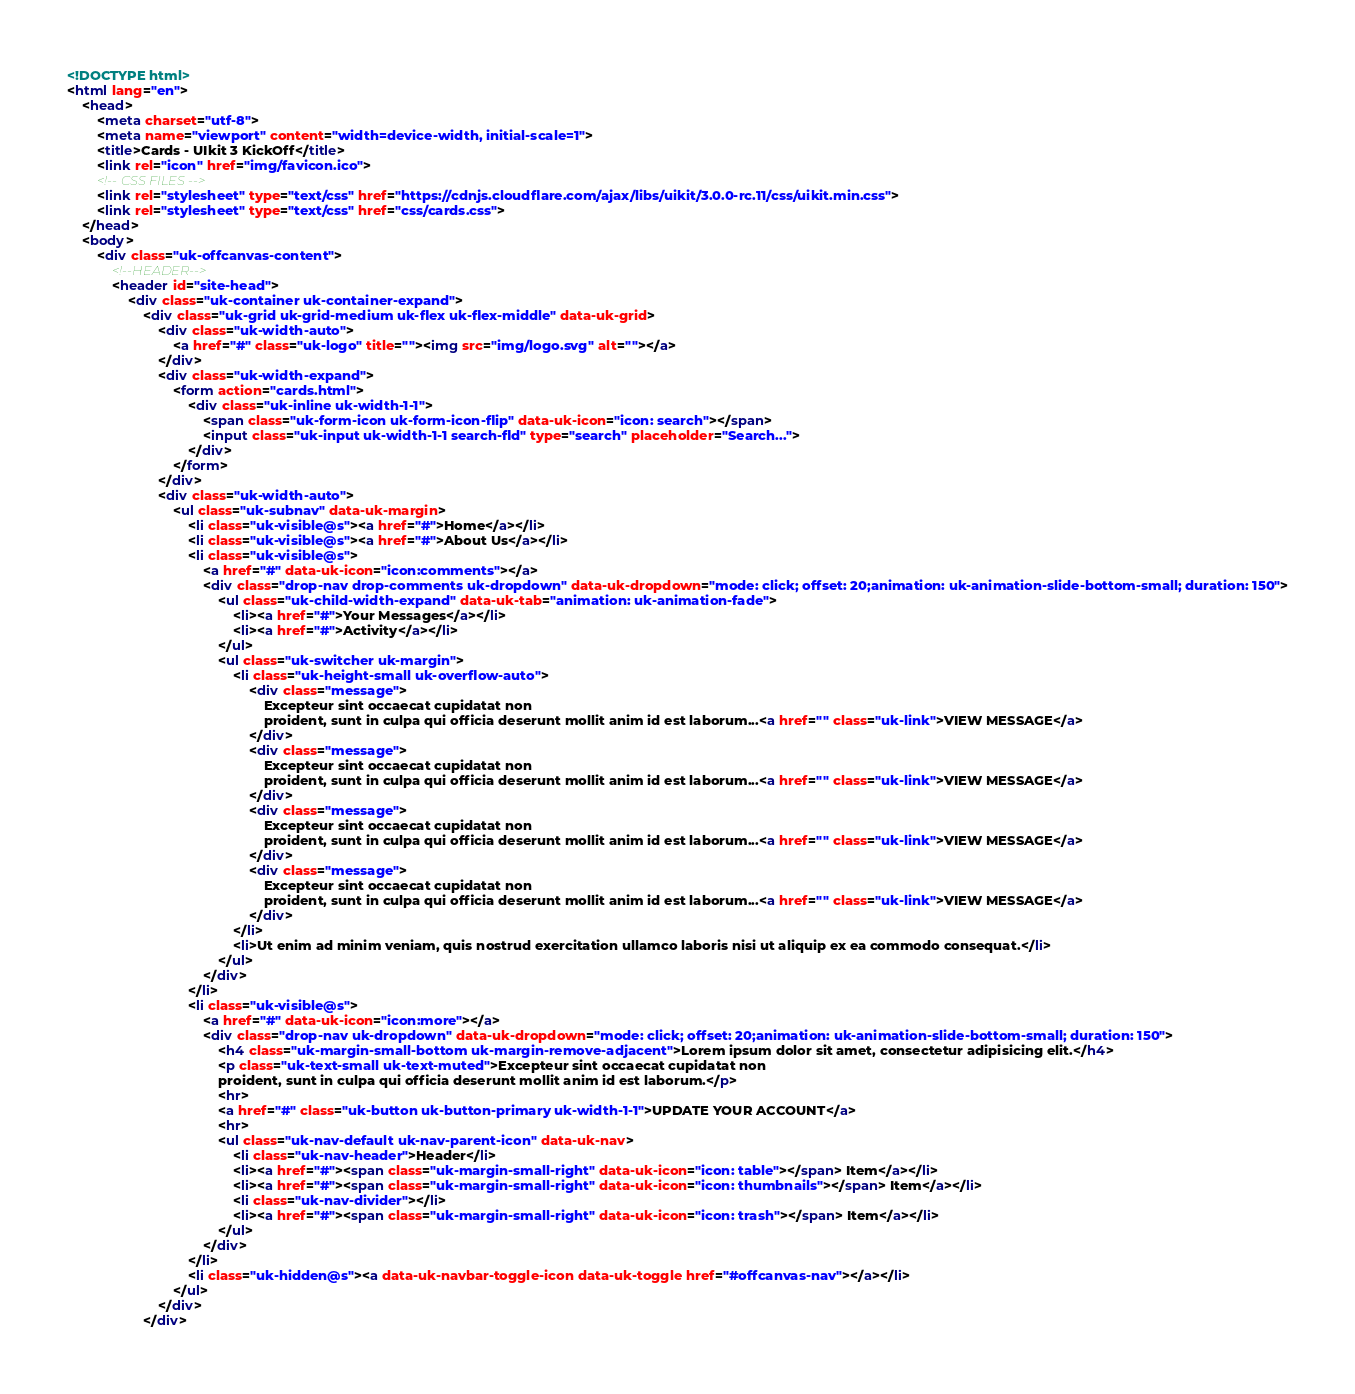Convert code to text. <code><loc_0><loc_0><loc_500><loc_500><_HTML_><!DOCTYPE html>
<html lang="en">
	<head>
		<meta charset="utf-8">
		<meta name="viewport" content="width=device-width, initial-scale=1">
		<title>Cards - UIkit 3 KickOff</title>
		<link rel="icon" href="img/favicon.ico">
		<!-- CSS FILES -->
		<link rel="stylesheet" type="text/css" href="https://cdnjs.cloudflare.com/ajax/libs/uikit/3.0.0-rc.11/css/uikit.min.css">
		<link rel="stylesheet" type="text/css" href="css/cards.css">
	</head>
	<body>
		<div class="uk-offcanvas-content">
			<!--HEADER-->
			<header id="site-head">
				<div class="uk-container uk-container-expand">
					<div class="uk-grid uk-grid-medium uk-flex uk-flex-middle" data-uk-grid>
						<div class="uk-width-auto">
							<a href="#" class="uk-logo" title=""><img src="img/logo.svg" alt=""></a>
						</div>
						<div class="uk-width-expand">
							<form action="cards.html">
								<div class="uk-inline uk-width-1-1">
									<span class="uk-form-icon uk-form-icon-flip" data-uk-icon="icon: search"></span>
									<input class="uk-input uk-width-1-1 search-fld" type="search" placeholder="Search...">
								</div>
							</form>
						</div>
						<div class="uk-width-auto">
							<ul class="uk-subnav" data-uk-margin>
								<li class="uk-visible@s"><a href="#">Home</a></li>
								<li class="uk-visible@s"><a href="#">About Us</a></li>
								<li class="uk-visible@s">
									<a href="#" data-uk-icon="icon:comments"></a>
									<div class="drop-nav drop-comments uk-dropdown" data-uk-dropdown="mode: click; offset: 20;animation: uk-animation-slide-bottom-small; duration: 150">
										<ul class="uk-child-width-expand" data-uk-tab="animation: uk-animation-fade">
											<li><a href="#">Your Messages</a></li>
											<li><a href="#">Activity</a></li>
										</ul>
										<ul class="uk-switcher uk-margin">
											<li class="uk-height-small uk-overflow-auto">
												<div class="message">
													Excepteur sint occaecat cupidatat non
													proident, sunt in culpa qui officia deserunt mollit anim id est laborum...<a href="" class="uk-link">VIEW MESSAGE</a>
												</div>
												<div class="message">
													Excepteur sint occaecat cupidatat non
													proident, sunt in culpa qui officia deserunt mollit anim id est laborum...<a href="" class="uk-link">VIEW MESSAGE</a>
												</div>
												<div class="message">
													Excepteur sint occaecat cupidatat non
													proident, sunt in culpa qui officia deserunt mollit anim id est laborum...<a href="" class="uk-link">VIEW MESSAGE</a>
												</div>
												<div class="message">
													Excepteur sint occaecat cupidatat non
													proident, sunt in culpa qui officia deserunt mollit anim id est laborum...<a href="" class="uk-link">VIEW MESSAGE</a>
												</div>
											</li>
											<li>Ut enim ad minim veniam, quis nostrud exercitation ullamco laboris nisi ut aliquip ex ea commodo consequat.</li>
										</ul>
									</div>
								</li>
								<li class="uk-visible@s">
									<a href="#" data-uk-icon="icon:more"></a>
									<div class="drop-nav uk-dropdown" data-uk-dropdown="mode: click; offset: 20;animation: uk-animation-slide-bottom-small; duration: 150">
										<h4 class="uk-margin-small-bottom uk-margin-remove-adjacent">Lorem ipsum dolor sit amet, consectetur adipisicing elit.</h4>
										<p class="uk-text-small uk-text-muted">Excepteur sint occaecat cupidatat non
										proident, sunt in culpa qui officia deserunt mollit anim id est laborum.</p>
										<hr>
										<a href="#" class="uk-button uk-button-primary uk-width-1-1">UPDATE YOUR ACCOUNT</a>
										<hr>
										<ul class="uk-nav-default uk-nav-parent-icon" data-uk-nav>
											<li class="uk-nav-header">Header</li>
											<li><a href="#"><span class="uk-margin-small-right" data-uk-icon="icon: table"></span> Item</a></li>
											<li><a href="#"><span class="uk-margin-small-right" data-uk-icon="icon: thumbnails"></span> Item</a></li>
											<li class="uk-nav-divider"></li>
											<li><a href="#"><span class="uk-margin-small-right" data-uk-icon="icon: trash"></span> Item</a></li>
										</ul>
									</div>
								</li>
								<li class="uk-hidden@s"><a data-uk-navbar-toggle-icon data-uk-toggle href="#offcanvas-nav"></a></li>
							</ul>
						</div>
					</div></code> 